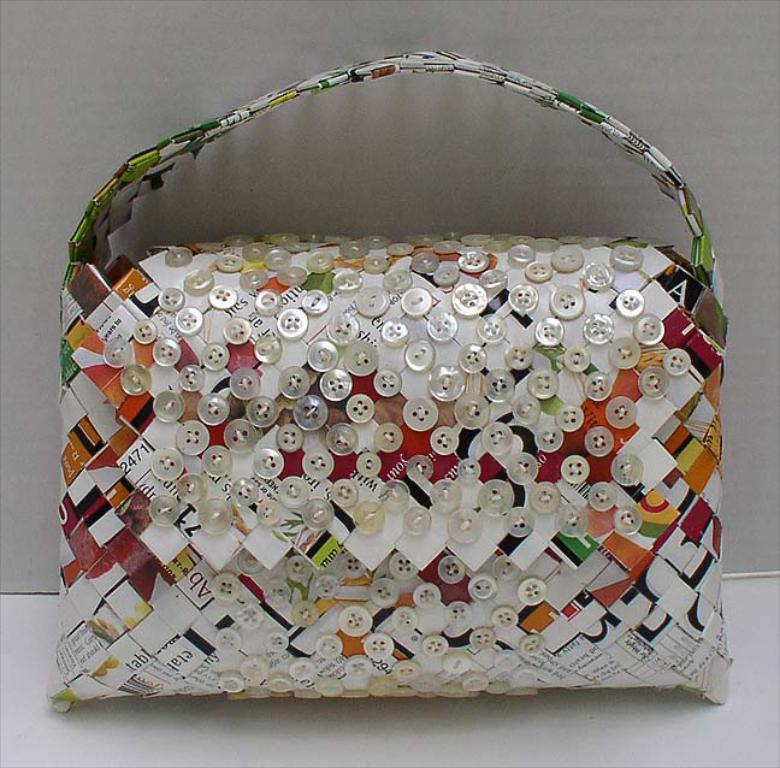What object is present in the image? There is a bag in the image. What feature can be seen on the bag? The bag has buttons stitched on it. What type of bread can be seen on the floor in the image? There is no bread or floor present in the image; it only features a bag with buttons stitched on it. 